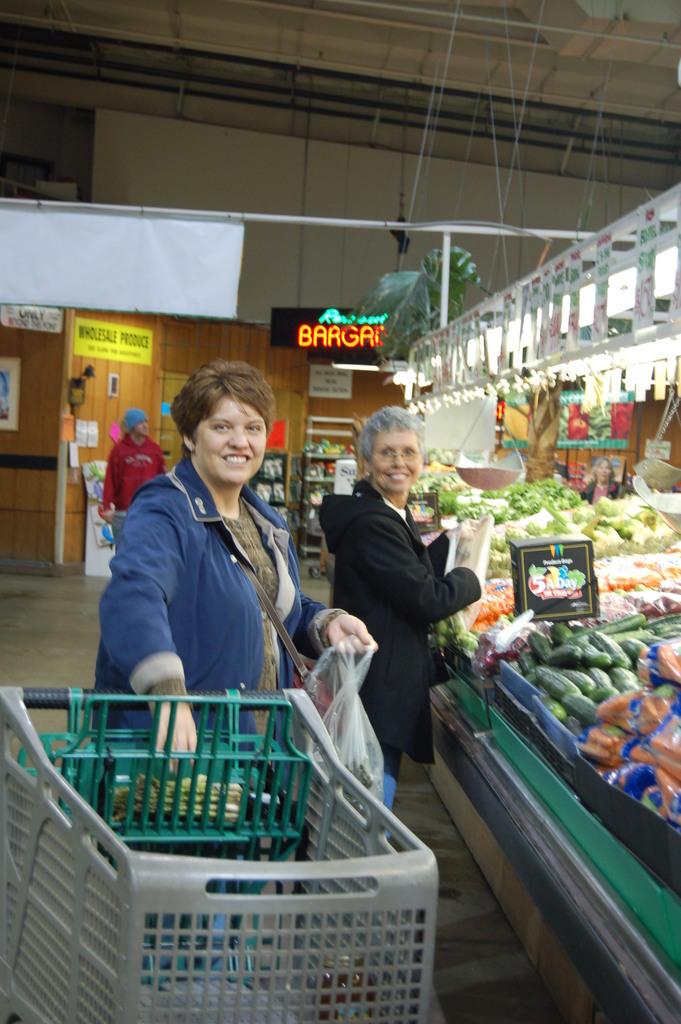How many vegtables does the sign say we need a day?
Give a very brief answer. 5. 